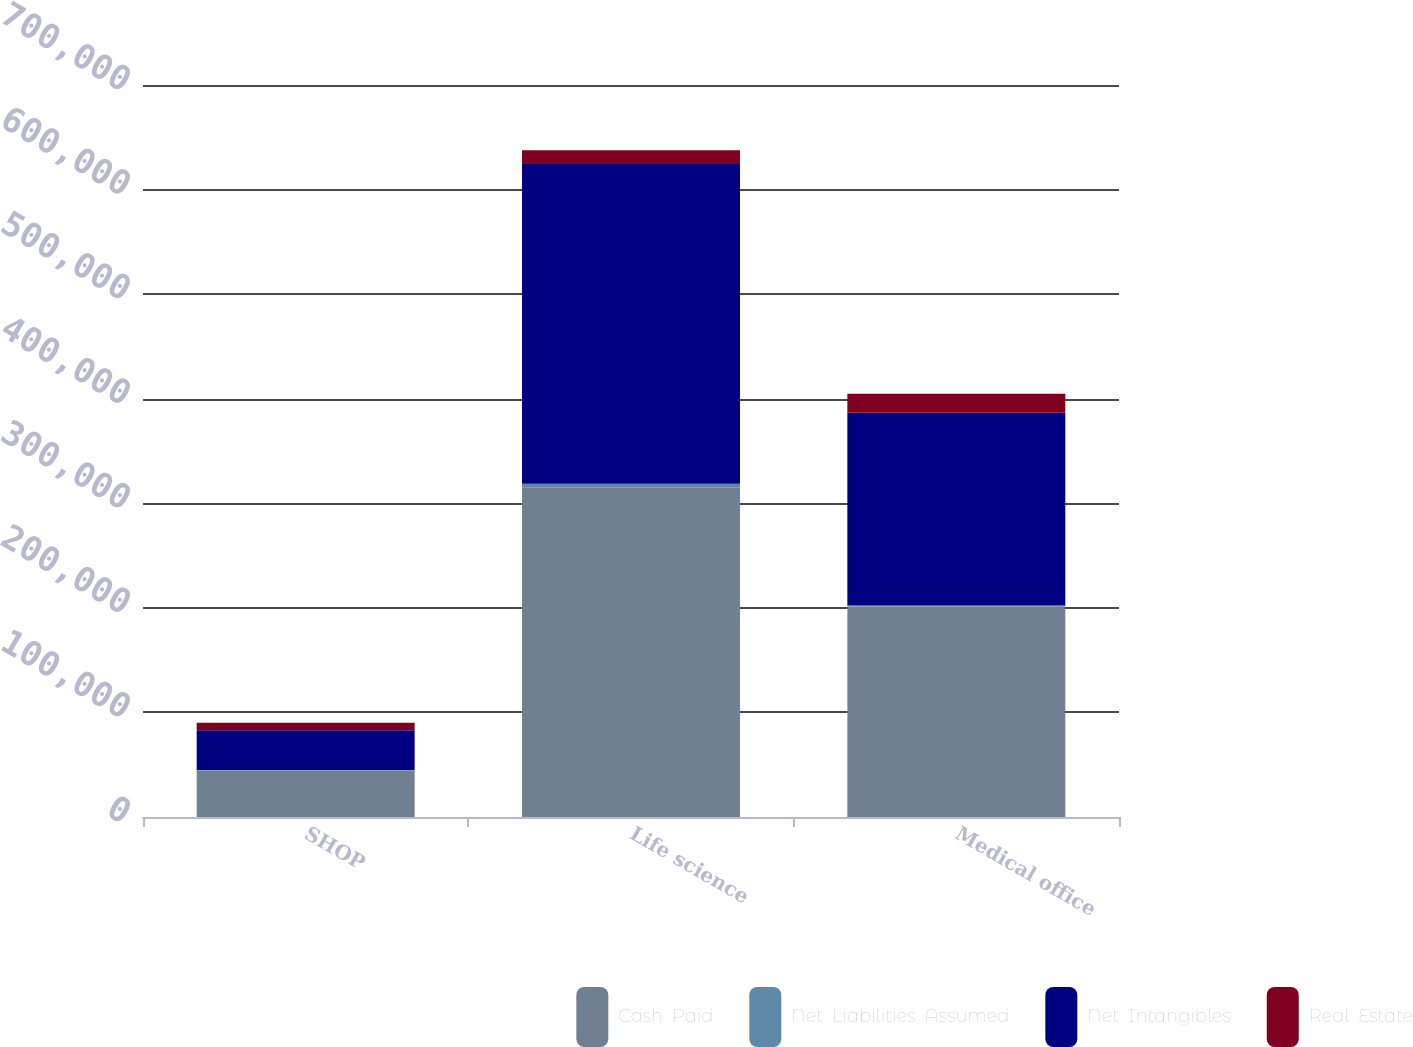<chart> <loc_0><loc_0><loc_500><loc_500><stacked_bar_chart><ecel><fcel>SHOP<fcel>Life science<fcel>Medical office<nl><fcel>Cash  Paid<fcel>44258<fcel>315255<fcel>201240<nl><fcel>Net  Liabilities  Assumed<fcel>797<fcel>3524<fcel>1104<nl><fcel>Net  Intangibles<fcel>37940<fcel>305760<fcel>184115<nl><fcel>Real  Estate<fcel>7115<fcel>13019<fcel>18229<nl></chart> 